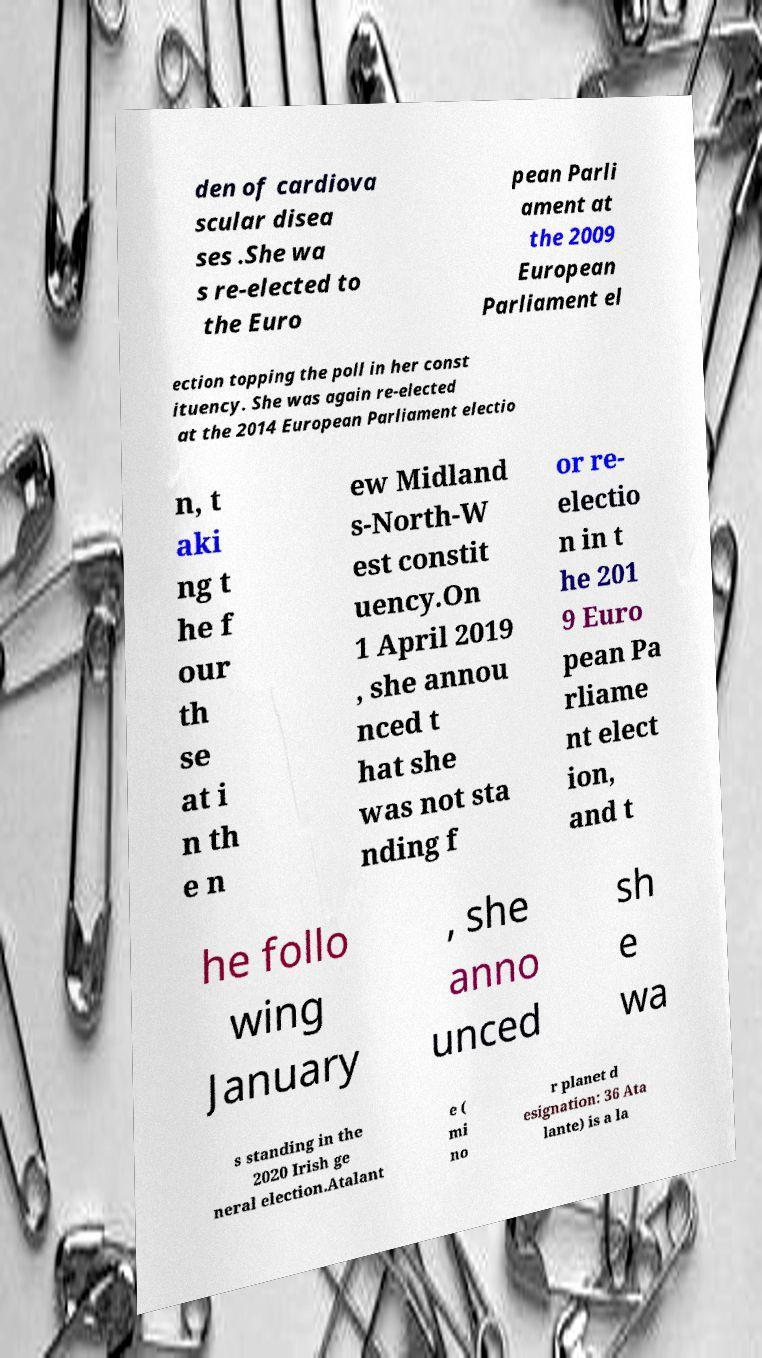Please read and relay the text visible in this image. What does it say? den of cardiova scular disea ses .She wa s re-elected to the Euro pean Parli ament at the 2009 European Parliament el ection topping the poll in her const ituency. She was again re-elected at the 2014 European Parliament electio n, t aki ng t he f our th se at i n th e n ew Midland s-North-W est constit uency.On 1 April 2019 , she annou nced t hat she was not sta nding f or re- electio n in t he 201 9 Euro pean Pa rliame nt elect ion, and t he follo wing January , she anno unced sh e wa s standing in the 2020 Irish ge neral election.Atalant e ( mi no r planet d esignation: 36 Ata lante) is a la 